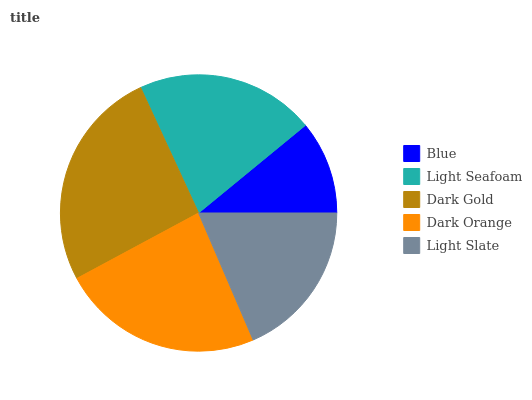Is Blue the minimum?
Answer yes or no. Yes. Is Dark Gold the maximum?
Answer yes or no. Yes. Is Light Seafoam the minimum?
Answer yes or no. No. Is Light Seafoam the maximum?
Answer yes or no. No. Is Light Seafoam greater than Blue?
Answer yes or no. Yes. Is Blue less than Light Seafoam?
Answer yes or no. Yes. Is Blue greater than Light Seafoam?
Answer yes or no. No. Is Light Seafoam less than Blue?
Answer yes or no. No. Is Light Seafoam the high median?
Answer yes or no. Yes. Is Light Seafoam the low median?
Answer yes or no. Yes. Is Dark Orange the high median?
Answer yes or no. No. Is Dark Orange the low median?
Answer yes or no. No. 